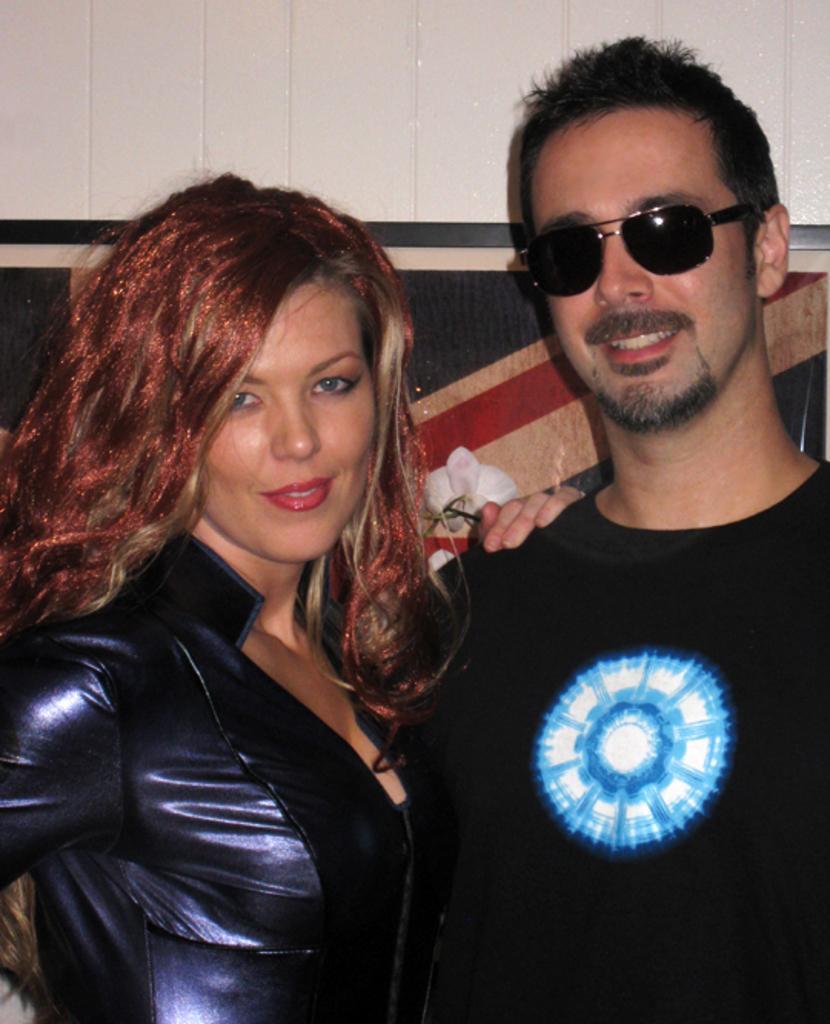How would you summarize this image in a sentence or two? In the center of the image we can see two persons are standing and they are smiling, which we can see on their faces. And the man is wearing sunglasses. In the background there is a wall and a few other objects. 